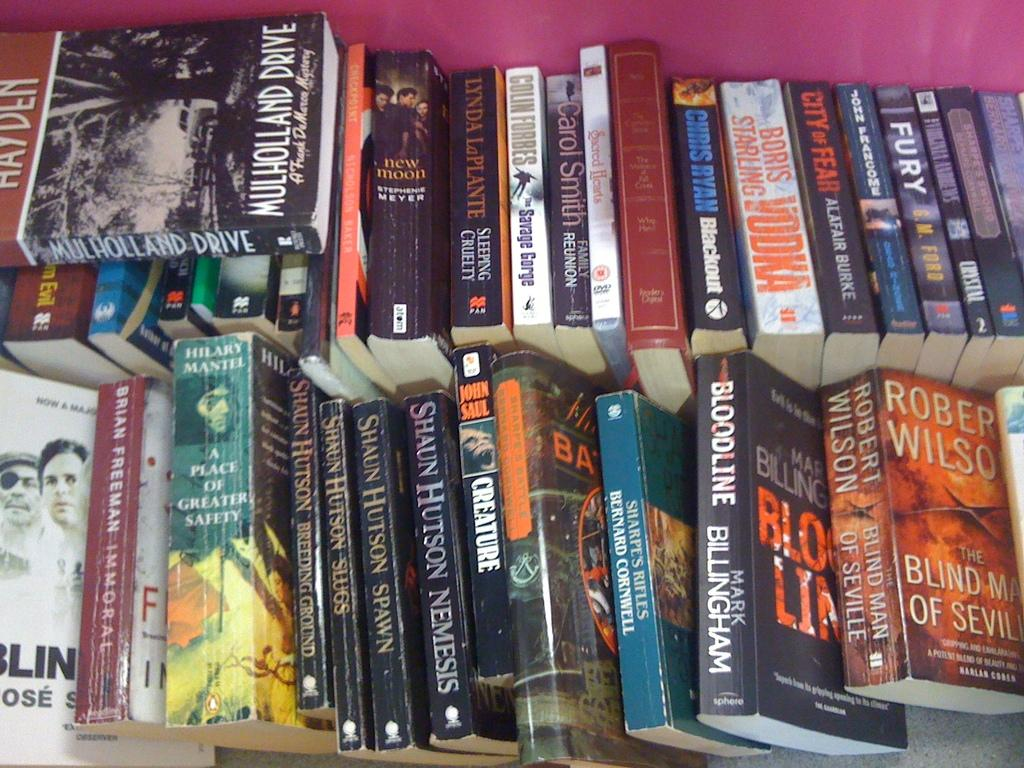<image>
Share a concise interpretation of the image provided. Many books lie next to each other in two rows, including titles such as Fury, Creature, and Blind Man Of Seville. 